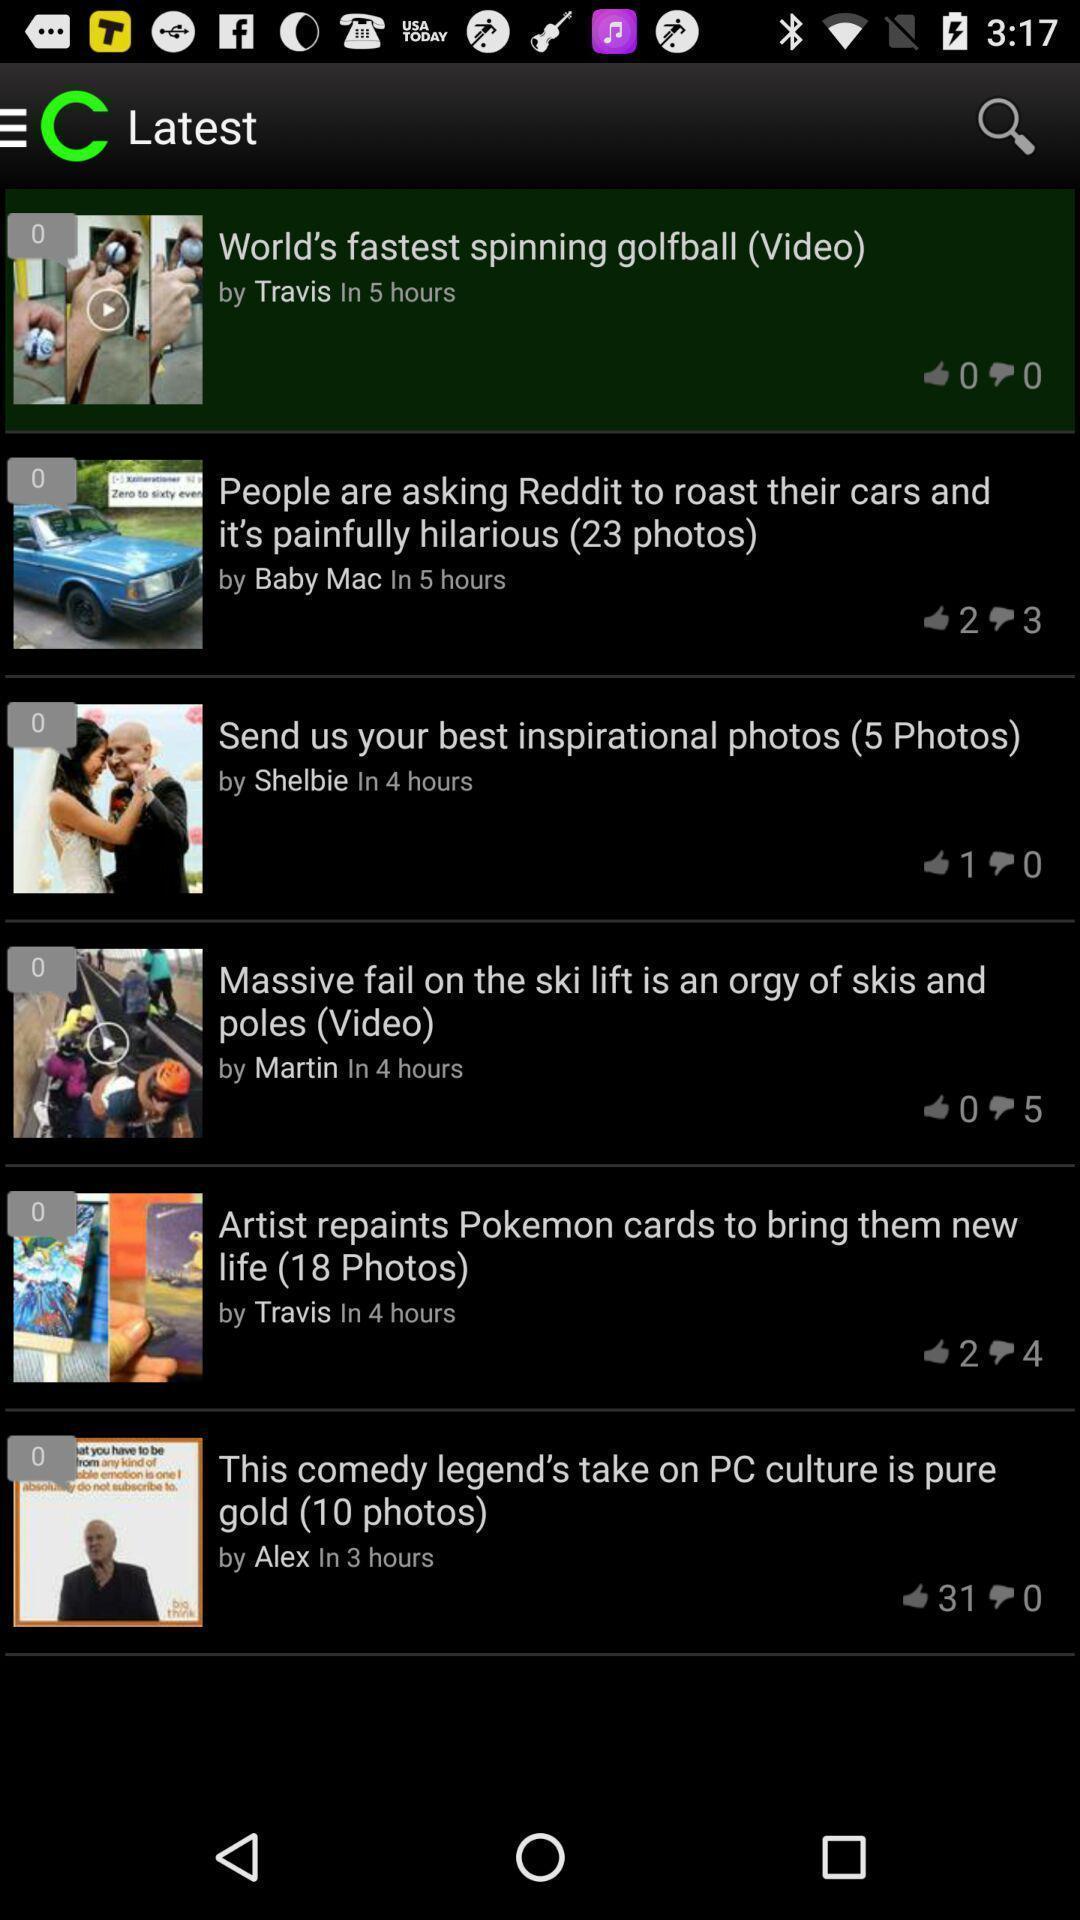Describe this image in words. Page showing variety of news. 